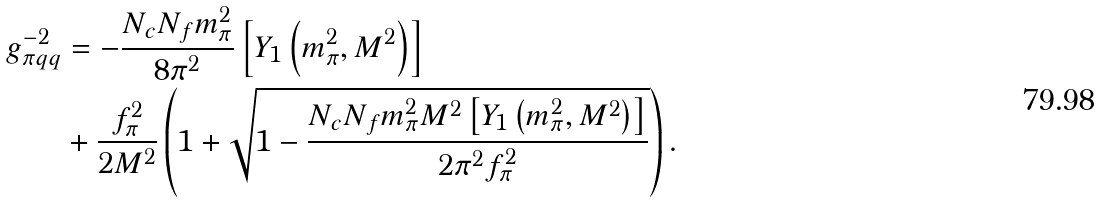<formula> <loc_0><loc_0><loc_500><loc_500>g _ { \pi q q } ^ { - 2 } & = - \frac { N _ { c } N _ { f } m _ { \pi } ^ { 2 } } { 8 \pi ^ { 2 } } \left [ Y _ { 1 } \left ( m _ { \pi } ^ { 2 } , M ^ { 2 } \right ) \right ] \\ & + \frac { f _ { \pi } ^ { 2 } } { 2 M ^ { 2 } } \left ( 1 + \sqrt { 1 - \frac { N _ { c } N _ { f } m _ { \pi } ^ { 2 } M ^ { 2 } \left [ Y _ { 1 } \left ( m _ { \pi } ^ { 2 } , M ^ { 2 } \right ) \right ] } { 2 \pi ^ { 2 } f _ { \pi } ^ { 2 } } } \right ) .</formula> 